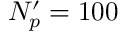<formula> <loc_0><loc_0><loc_500><loc_500>N _ { p } ^ { \prime } = 1 0 0</formula> 